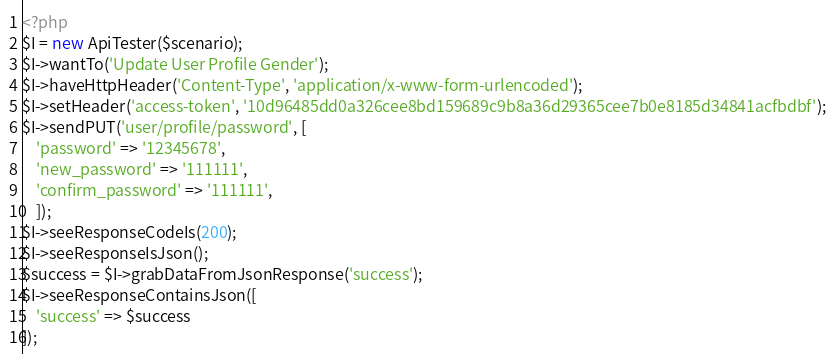Convert code to text. <code><loc_0><loc_0><loc_500><loc_500><_PHP_><?php 
$I = new ApiTester($scenario);
$I->wantTo('Update User Profile Gender');
$I->haveHttpHeader('Content-Type', 'application/x-www-form-urlencoded');
$I->setHeader('access-token', '10d96485dd0a326cee8bd159689c9b8a36d29365cee7b0e8185d34841acfbdbf');
$I->sendPUT('user/profile/password', [
    'password' => '12345678',
    'new_password' => '111111',
    'confirm_password' => '111111',
    ]);
$I->seeResponseCodeIs(200);
$I->seeResponseIsJson();
$success = $I->grabDataFromJsonResponse('success');
$I->seeResponseContainsJson([
    'success' => $success
]);</code> 